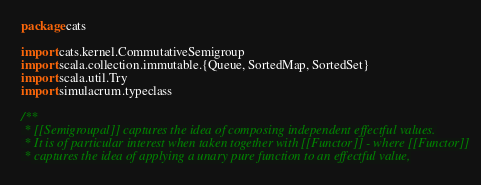<code> <loc_0><loc_0><loc_500><loc_500><_Scala_>package cats

import cats.kernel.CommutativeSemigroup
import scala.collection.immutable.{Queue, SortedMap, SortedSet}
import scala.util.Try
import simulacrum.typeclass

/**
 * [[Semigroupal]] captures the idea of composing independent effectful values.
 * It is of particular interest when taken together with [[Functor]] - where [[Functor]]
 * captures the idea of applying a unary pure function to an effectful value,</code> 